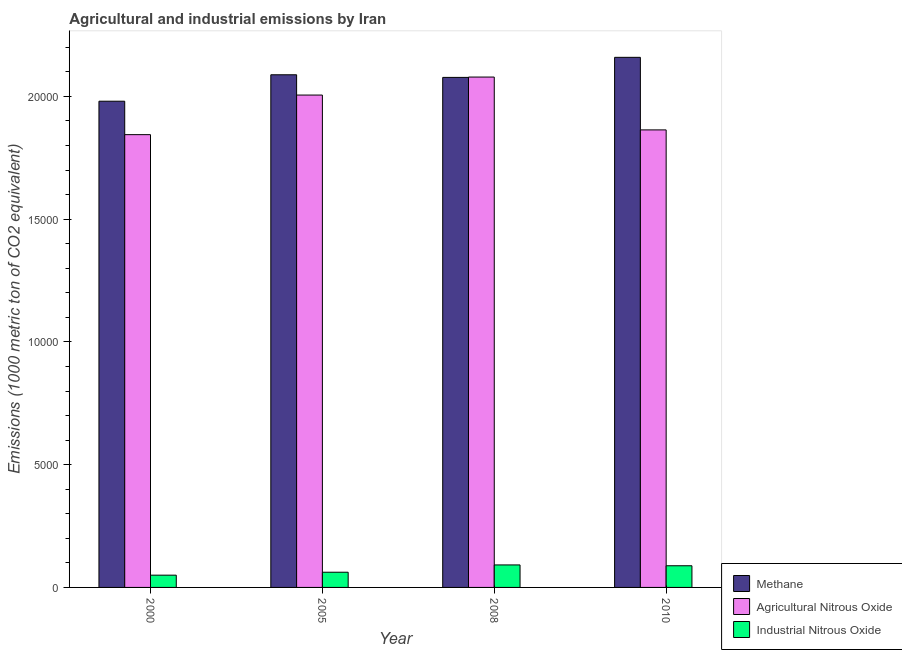How many groups of bars are there?
Make the answer very short. 4. Are the number of bars per tick equal to the number of legend labels?
Ensure brevity in your answer.  Yes. How many bars are there on the 4th tick from the left?
Your response must be concise. 3. In how many cases, is the number of bars for a given year not equal to the number of legend labels?
Your answer should be compact. 0. What is the amount of agricultural nitrous oxide emissions in 2000?
Give a very brief answer. 1.84e+04. Across all years, what is the maximum amount of methane emissions?
Offer a very short reply. 2.16e+04. Across all years, what is the minimum amount of industrial nitrous oxide emissions?
Your answer should be compact. 499.4. In which year was the amount of industrial nitrous oxide emissions maximum?
Your answer should be very brief. 2008. What is the total amount of methane emissions in the graph?
Offer a terse response. 8.31e+04. What is the difference between the amount of methane emissions in 2000 and that in 2010?
Offer a very short reply. -1787.7. What is the difference between the amount of industrial nitrous oxide emissions in 2000 and the amount of agricultural nitrous oxide emissions in 2008?
Ensure brevity in your answer.  -416.8. What is the average amount of agricultural nitrous oxide emissions per year?
Provide a succinct answer. 1.95e+04. In the year 2005, what is the difference between the amount of methane emissions and amount of agricultural nitrous oxide emissions?
Give a very brief answer. 0. What is the ratio of the amount of agricultural nitrous oxide emissions in 2000 to that in 2010?
Keep it short and to the point. 0.99. Is the amount of industrial nitrous oxide emissions in 2008 less than that in 2010?
Your answer should be very brief. No. Is the difference between the amount of methane emissions in 2005 and 2008 greater than the difference between the amount of industrial nitrous oxide emissions in 2005 and 2008?
Keep it short and to the point. No. What is the difference between the highest and the second highest amount of industrial nitrous oxide emissions?
Your response must be concise. 33.7. What is the difference between the highest and the lowest amount of methane emissions?
Offer a terse response. 1787.7. In how many years, is the amount of methane emissions greater than the average amount of methane emissions taken over all years?
Provide a succinct answer. 3. What does the 1st bar from the left in 2010 represents?
Provide a short and direct response. Methane. What does the 1st bar from the right in 2000 represents?
Ensure brevity in your answer.  Industrial Nitrous Oxide. Are all the bars in the graph horizontal?
Offer a terse response. No. How many years are there in the graph?
Give a very brief answer. 4. Are the values on the major ticks of Y-axis written in scientific E-notation?
Give a very brief answer. No. Does the graph contain any zero values?
Provide a succinct answer. No. Where does the legend appear in the graph?
Keep it short and to the point. Bottom right. How many legend labels are there?
Offer a very short reply. 3. How are the legend labels stacked?
Your answer should be compact. Vertical. What is the title of the graph?
Your answer should be very brief. Agricultural and industrial emissions by Iran. What is the label or title of the Y-axis?
Provide a short and direct response. Emissions (1000 metric ton of CO2 equivalent). What is the Emissions (1000 metric ton of CO2 equivalent) of Methane in 2000?
Your response must be concise. 1.98e+04. What is the Emissions (1000 metric ton of CO2 equivalent) of Agricultural Nitrous Oxide in 2000?
Offer a terse response. 1.84e+04. What is the Emissions (1000 metric ton of CO2 equivalent) of Industrial Nitrous Oxide in 2000?
Offer a very short reply. 499.4. What is the Emissions (1000 metric ton of CO2 equivalent) of Methane in 2005?
Provide a succinct answer. 2.09e+04. What is the Emissions (1000 metric ton of CO2 equivalent) in Agricultural Nitrous Oxide in 2005?
Make the answer very short. 2.01e+04. What is the Emissions (1000 metric ton of CO2 equivalent) in Industrial Nitrous Oxide in 2005?
Provide a short and direct response. 619.4. What is the Emissions (1000 metric ton of CO2 equivalent) of Methane in 2008?
Provide a short and direct response. 2.08e+04. What is the Emissions (1000 metric ton of CO2 equivalent) in Agricultural Nitrous Oxide in 2008?
Your answer should be compact. 2.08e+04. What is the Emissions (1000 metric ton of CO2 equivalent) in Industrial Nitrous Oxide in 2008?
Offer a terse response. 916.2. What is the Emissions (1000 metric ton of CO2 equivalent) of Methane in 2010?
Make the answer very short. 2.16e+04. What is the Emissions (1000 metric ton of CO2 equivalent) in Agricultural Nitrous Oxide in 2010?
Provide a short and direct response. 1.86e+04. What is the Emissions (1000 metric ton of CO2 equivalent) of Industrial Nitrous Oxide in 2010?
Your answer should be compact. 882.5. Across all years, what is the maximum Emissions (1000 metric ton of CO2 equivalent) in Methane?
Offer a very short reply. 2.16e+04. Across all years, what is the maximum Emissions (1000 metric ton of CO2 equivalent) of Agricultural Nitrous Oxide?
Your response must be concise. 2.08e+04. Across all years, what is the maximum Emissions (1000 metric ton of CO2 equivalent) of Industrial Nitrous Oxide?
Keep it short and to the point. 916.2. Across all years, what is the minimum Emissions (1000 metric ton of CO2 equivalent) of Methane?
Your response must be concise. 1.98e+04. Across all years, what is the minimum Emissions (1000 metric ton of CO2 equivalent) of Agricultural Nitrous Oxide?
Your answer should be compact. 1.84e+04. Across all years, what is the minimum Emissions (1000 metric ton of CO2 equivalent) in Industrial Nitrous Oxide?
Your answer should be compact. 499.4. What is the total Emissions (1000 metric ton of CO2 equivalent) in Methane in the graph?
Your answer should be compact. 8.31e+04. What is the total Emissions (1000 metric ton of CO2 equivalent) in Agricultural Nitrous Oxide in the graph?
Keep it short and to the point. 7.79e+04. What is the total Emissions (1000 metric ton of CO2 equivalent) of Industrial Nitrous Oxide in the graph?
Keep it short and to the point. 2917.5. What is the difference between the Emissions (1000 metric ton of CO2 equivalent) of Methane in 2000 and that in 2005?
Your answer should be very brief. -1076.9. What is the difference between the Emissions (1000 metric ton of CO2 equivalent) of Agricultural Nitrous Oxide in 2000 and that in 2005?
Your answer should be very brief. -1612.7. What is the difference between the Emissions (1000 metric ton of CO2 equivalent) of Industrial Nitrous Oxide in 2000 and that in 2005?
Your answer should be very brief. -120. What is the difference between the Emissions (1000 metric ton of CO2 equivalent) in Methane in 2000 and that in 2008?
Offer a very short reply. -970.2. What is the difference between the Emissions (1000 metric ton of CO2 equivalent) of Agricultural Nitrous Oxide in 2000 and that in 2008?
Offer a very short reply. -2346. What is the difference between the Emissions (1000 metric ton of CO2 equivalent) in Industrial Nitrous Oxide in 2000 and that in 2008?
Your response must be concise. -416.8. What is the difference between the Emissions (1000 metric ton of CO2 equivalent) of Methane in 2000 and that in 2010?
Make the answer very short. -1787.7. What is the difference between the Emissions (1000 metric ton of CO2 equivalent) of Agricultural Nitrous Oxide in 2000 and that in 2010?
Provide a succinct answer. -194. What is the difference between the Emissions (1000 metric ton of CO2 equivalent) in Industrial Nitrous Oxide in 2000 and that in 2010?
Offer a very short reply. -383.1. What is the difference between the Emissions (1000 metric ton of CO2 equivalent) in Methane in 2005 and that in 2008?
Provide a succinct answer. 106.7. What is the difference between the Emissions (1000 metric ton of CO2 equivalent) of Agricultural Nitrous Oxide in 2005 and that in 2008?
Offer a very short reply. -733.3. What is the difference between the Emissions (1000 metric ton of CO2 equivalent) in Industrial Nitrous Oxide in 2005 and that in 2008?
Your response must be concise. -296.8. What is the difference between the Emissions (1000 metric ton of CO2 equivalent) in Methane in 2005 and that in 2010?
Provide a succinct answer. -710.8. What is the difference between the Emissions (1000 metric ton of CO2 equivalent) of Agricultural Nitrous Oxide in 2005 and that in 2010?
Offer a terse response. 1418.7. What is the difference between the Emissions (1000 metric ton of CO2 equivalent) of Industrial Nitrous Oxide in 2005 and that in 2010?
Provide a succinct answer. -263.1. What is the difference between the Emissions (1000 metric ton of CO2 equivalent) in Methane in 2008 and that in 2010?
Keep it short and to the point. -817.5. What is the difference between the Emissions (1000 metric ton of CO2 equivalent) of Agricultural Nitrous Oxide in 2008 and that in 2010?
Provide a short and direct response. 2152. What is the difference between the Emissions (1000 metric ton of CO2 equivalent) in Industrial Nitrous Oxide in 2008 and that in 2010?
Give a very brief answer. 33.7. What is the difference between the Emissions (1000 metric ton of CO2 equivalent) of Methane in 2000 and the Emissions (1000 metric ton of CO2 equivalent) of Agricultural Nitrous Oxide in 2005?
Your answer should be very brief. -250.7. What is the difference between the Emissions (1000 metric ton of CO2 equivalent) in Methane in 2000 and the Emissions (1000 metric ton of CO2 equivalent) in Industrial Nitrous Oxide in 2005?
Offer a terse response. 1.92e+04. What is the difference between the Emissions (1000 metric ton of CO2 equivalent) in Agricultural Nitrous Oxide in 2000 and the Emissions (1000 metric ton of CO2 equivalent) in Industrial Nitrous Oxide in 2005?
Your answer should be compact. 1.78e+04. What is the difference between the Emissions (1000 metric ton of CO2 equivalent) in Methane in 2000 and the Emissions (1000 metric ton of CO2 equivalent) in Agricultural Nitrous Oxide in 2008?
Give a very brief answer. -984. What is the difference between the Emissions (1000 metric ton of CO2 equivalent) in Methane in 2000 and the Emissions (1000 metric ton of CO2 equivalent) in Industrial Nitrous Oxide in 2008?
Keep it short and to the point. 1.89e+04. What is the difference between the Emissions (1000 metric ton of CO2 equivalent) of Agricultural Nitrous Oxide in 2000 and the Emissions (1000 metric ton of CO2 equivalent) of Industrial Nitrous Oxide in 2008?
Ensure brevity in your answer.  1.75e+04. What is the difference between the Emissions (1000 metric ton of CO2 equivalent) of Methane in 2000 and the Emissions (1000 metric ton of CO2 equivalent) of Agricultural Nitrous Oxide in 2010?
Give a very brief answer. 1168. What is the difference between the Emissions (1000 metric ton of CO2 equivalent) of Methane in 2000 and the Emissions (1000 metric ton of CO2 equivalent) of Industrial Nitrous Oxide in 2010?
Provide a short and direct response. 1.89e+04. What is the difference between the Emissions (1000 metric ton of CO2 equivalent) in Agricultural Nitrous Oxide in 2000 and the Emissions (1000 metric ton of CO2 equivalent) in Industrial Nitrous Oxide in 2010?
Keep it short and to the point. 1.76e+04. What is the difference between the Emissions (1000 metric ton of CO2 equivalent) in Methane in 2005 and the Emissions (1000 metric ton of CO2 equivalent) in Agricultural Nitrous Oxide in 2008?
Give a very brief answer. 92.9. What is the difference between the Emissions (1000 metric ton of CO2 equivalent) in Methane in 2005 and the Emissions (1000 metric ton of CO2 equivalent) in Industrial Nitrous Oxide in 2008?
Provide a short and direct response. 2.00e+04. What is the difference between the Emissions (1000 metric ton of CO2 equivalent) of Agricultural Nitrous Oxide in 2005 and the Emissions (1000 metric ton of CO2 equivalent) of Industrial Nitrous Oxide in 2008?
Your response must be concise. 1.91e+04. What is the difference between the Emissions (1000 metric ton of CO2 equivalent) of Methane in 2005 and the Emissions (1000 metric ton of CO2 equivalent) of Agricultural Nitrous Oxide in 2010?
Your answer should be compact. 2244.9. What is the difference between the Emissions (1000 metric ton of CO2 equivalent) of Methane in 2005 and the Emissions (1000 metric ton of CO2 equivalent) of Industrial Nitrous Oxide in 2010?
Provide a short and direct response. 2.00e+04. What is the difference between the Emissions (1000 metric ton of CO2 equivalent) in Agricultural Nitrous Oxide in 2005 and the Emissions (1000 metric ton of CO2 equivalent) in Industrial Nitrous Oxide in 2010?
Make the answer very short. 1.92e+04. What is the difference between the Emissions (1000 metric ton of CO2 equivalent) in Methane in 2008 and the Emissions (1000 metric ton of CO2 equivalent) in Agricultural Nitrous Oxide in 2010?
Your answer should be compact. 2138.2. What is the difference between the Emissions (1000 metric ton of CO2 equivalent) in Methane in 2008 and the Emissions (1000 metric ton of CO2 equivalent) in Industrial Nitrous Oxide in 2010?
Give a very brief answer. 1.99e+04. What is the difference between the Emissions (1000 metric ton of CO2 equivalent) in Agricultural Nitrous Oxide in 2008 and the Emissions (1000 metric ton of CO2 equivalent) in Industrial Nitrous Oxide in 2010?
Provide a short and direct response. 1.99e+04. What is the average Emissions (1000 metric ton of CO2 equivalent) of Methane per year?
Provide a short and direct response. 2.08e+04. What is the average Emissions (1000 metric ton of CO2 equivalent) of Agricultural Nitrous Oxide per year?
Your answer should be very brief. 1.95e+04. What is the average Emissions (1000 metric ton of CO2 equivalent) of Industrial Nitrous Oxide per year?
Provide a short and direct response. 729.38. In the year 2000, what is the difference between the Emissions (1000 metric ton of CO2 equivalent) of Methane and Emissions (1000 metric ton of CO2 equivalent) of Agricultural Nitrous Oxide?
Your answer should be compact. 1362. In the year 2000, what is the difference between the Emissions (1000 metric ton of CO2 equivalent) of Methane and Emissions (1000 metric ton of CO2 equivalent) of Industrial Nitrous Oxide?
Give a very brief answer. 1.93e+04. In the year 2000, what is the difference between the Emissions (1000 metric ton of CO2 equivalent) of Agricultural Nitrous Oxide and Emissions (1000 metric ton of CO2 equivalent) of Industrial Nitrous Oxide?
Offer a terse response. 1.79e+04. In the year 2005, what is the difference between the Emissions (1000 metric ton of CO2 equivalent) of Methane and Emissions (1000 metric ton of CO2 equivalent) of Agricultural Nitrous Oxide?
Your response must be concise. 826.2. In the year 2005, what is the difference between the Emissions (1000 metric ton of CO2 equivalent) of Methane and Emissions (1000 metric ton of CO2 equivalent) of Industrial Nitrous Oxide?
Your answer should be compact. 2.03e+04. In the year 2005, what is the difference between the Emissions (1000 metric ton of CO2 equivalent) in Agricultural Nitrous Oxide and Emissions (1000 metric ton of CO2 equivalent) in Industrial Nitrous Oxide?
Ensure brevity in your answer.  1.94e+04. In the year 2008, what is the difference between the Emissions (1000 metric ton of CO2 equivalent) of Methane and Emissions (1000 metric ton of CO2 equivalent) of Industrial Nitrous Oxide?
Make the answer very short. 1.99e+04. In the year 2008, what is the difference between the Emissions (1000 metric ton of CO2 equivalent) in Agricultural Nitrous Oxide and Emissions (1000 metric ton of CO2 equivalent) in Industrial Nitrous Oxide?
Ensure brevity in your answer.  1.99e+04. In the year 2010, what is the difference between the Emissions (1000 metric ton of CO2 equivalent) in Methane and Emissions (1000 metric ton of CO2 equivalent) in Agricultural Nitrous Oxide?
Your response must be concise. 2955.7. In the year 2010, what is the difference between the Emissions (1000 metric ton of CO2 equivalent) of Methane and Emissions (1000 metric ton of CO2 equivalent) of Industrial Nitrous Oxide?
Offer a very short reply. 2.07e+04. In the year 2010, what is the difference between the Emissions (1000 metric ton of CO2 equivalent) in Agricultural Nitrous Oxide and Emissions (1000 metric ton of CO2 equivalent) in Industrial Nitrous Oxide?
Keep it short and to the point. 1.78e+04. What is the ratio of the Emissions (1000 metric ton of CO2 equivalent) in Methane in 2000 to that in 2005?
Offer a very short reply. 0.95. What is the ratio of the Emissions (1000 metric ton of CO2 equivalent) of Agricultural Nitrous Oxide in 2000 to that in 2005?
Your answer should be very brief. 0.92. What is the ratio of the Emissions (1000 metric ton of CO2 equivalent) in Industrial Nitrous Oxide in 2000 to that in 2005?
Give a very brief answer. 0.81. What is the ratio of the Emissions (1000 metric ton of CO2 equivalent) of Methane in 2000 to that in 2008?
Your response must be concise. 0.95. What is the ratio of the Emissions (1000 metric ton of CO2 equivalent) of Agricultural Nitrous Oxide in 2000 to that in 2008?
Keep it short and to the point. 0.89. What is the ratio of the Emissions (1000 metric ton of CO2 equivalent) in Industrial Nitrous Oxide in 2000 to that in 2008?
Your answer should be very brief. 0.55. What is the ratio of the Emissions (1000 metric ton of CO2 equivalent) of Methane in 2000 to that in 2010?
Keep it short and to the point. 0.92. What is the ratio of the Emissions (1000 metric ton of CO2 equivalent) of Agricultural Nitrous Oxide in 2000 to that in 2010?
Give a very brief answer. 0.99. What is the ratio of the Emissions (1000 metric ton of CO2 equivalent) of Industrial Nitrous Oxide in 2000 to that in 2010?
Ensure brevity in your answer.  0.57. What is the ratio of the Emissions (1000 metric ton of CO2 equivalent) of Methane in 2005 to that in 2008?
Ensure brevity in your answer.  1.01. What is the ratio of the Emissions (1000 metric ton of CO2 equivalent) in Agricultural Nitrous Oxide in 2005 to that in 2008?
Provide a succinct answer. 0.96. What is the ratio of the Emissions (1000 metric ton of CO2 equivalent) in Industrial Nitrous Oxide in 2005 to that in 2008?
Offer a very short reply. 0.68. What is the ratio of the Emissions (1000 metric ton of CO2 equivalent) in Methane in 2005 to that in 2010?
Offer a terse response. 0.97. What is the ratio of the Emissions (1000 metric ton of CO2 equivalent) in Agricultural Nitrous Oxide in 2005 to that in 2010?
Ensure brevity in your answer.  1.08. What is the ratio of the Emissions (1000 metric ton of CO2 equivalent) of Industrial Nitrous Oxide in 2005 to that in 2010?
Give a very brief answer. 0.7. What is the ratio of the Emissions (1000 metric ton of CO2 equivalent) of Methane in 2008 to that in 2010?
Offer a very short reply. 0.96. What is the ratio of the Emissions (1000 metric ton of CO2 equivalent) in Agricultural Nitrous Oxide in 2008 to that in 2010?
Offer a terse response. 1.12. What is the ratio of the Emissions (1000 metric ton of CO2 equivalent) of Industrial Nitrous Oxide in 2008 to that in 2010?
Your answer should be compact. 1.04. What is the difference between the highest and the second highest Emissions (1000 metric ton of CO2 equivalent) of Methane?
Ensure brevity in your answer.  710.8. What is the difference between the highest and the second highest Emissions (1000 metric ton of CO2 equivalent) of Agricultural Nitrous Oxide?
Give a very brief answer. 733.3. What is the difference between the highest and the second highest Emissions (1000 metric ton of CO2 equivalent) in Industrial Nitrous Oxide?
Your response must be concise. 33.7. What is the difference between the highest and the lowest Emissions (1000 metric ton of CO2 equivalent) of Methane?
Provide a short and direct response. 1787.7. What is the difference between the highest and the lowest Emissions (1000 metric ton of CO2 equivalent) of Agricultural Nitrous Oxide?
Your answer should be very brief. 2346. What is the difference between the highest and the lowest Emissions (1000 metric ton of CO2 equivalent) in Industrial Nitrous Oxide?
Provide a short and direct response. 416.8. 